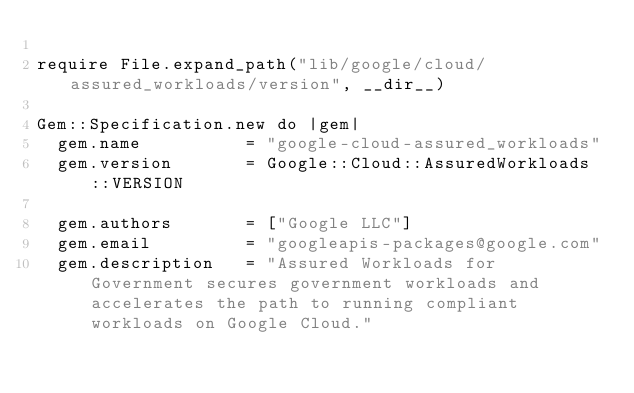<code> <loc_0><loc_0><loc_500><loc_500><_Ruby_>
require File.expand_path("lib/google/cloud/assured_workloads/version", __dir__)

Gem::Specification.new do |gem|
  gem.name          = "google-cloud-assured_workloads"
  gem.version       = Google::Cloud::AssuredWorkloads::VERSION

  gem.authors       = ["Google LLC"]
  gem.email         = "googleapis-packages@google.com"
  gem.description   = "Assured Workloads for Government secures government workloads and accelerates the path to running compliant workloads on Google Cloud."</code> 